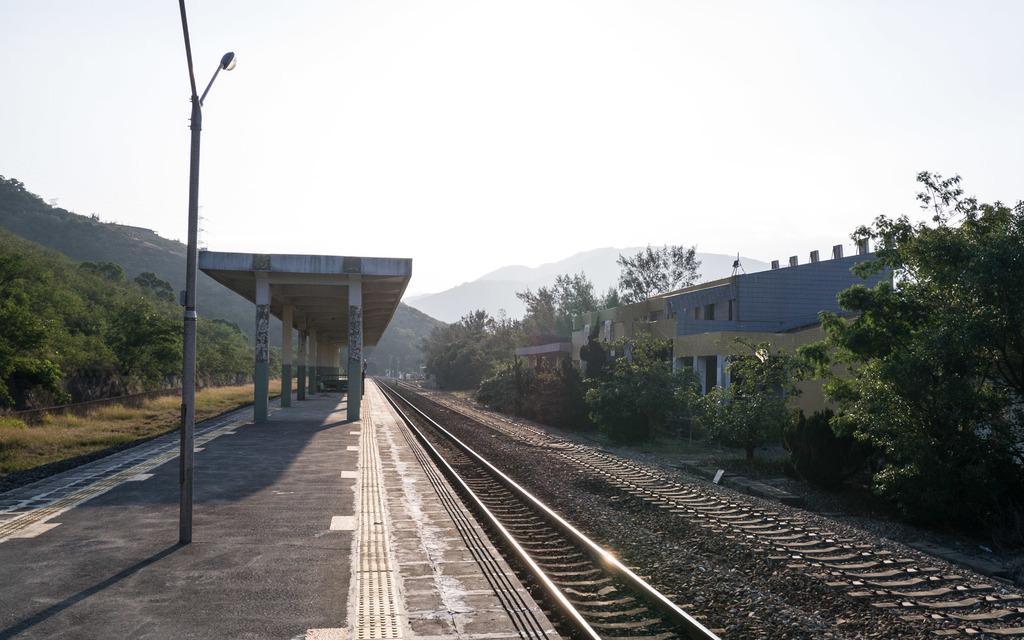Please provide a concise description of this image. In this image there is a rock structure on the pavement and there is a pole with the street lights, in front of the pavement there is a railway track. On the right side of the image there are buildings and trees. On the left side of the image there are trees in the background there are mountains and this sky. 